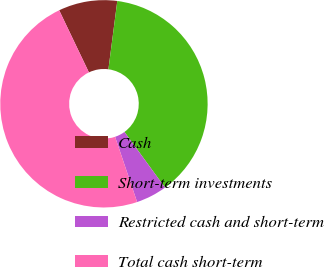<chart> <loc_0><loc_0><loc_500><loc_500><pie_chart><fcel>Cash<fcel>Short-term investments<fcel>Restricted cash and short-term<fcel>Total cash short-term<nl><fcel>9.16%<fcel>37.92%<fcel>4.84%<fcel>48.08%<nl></chart> 